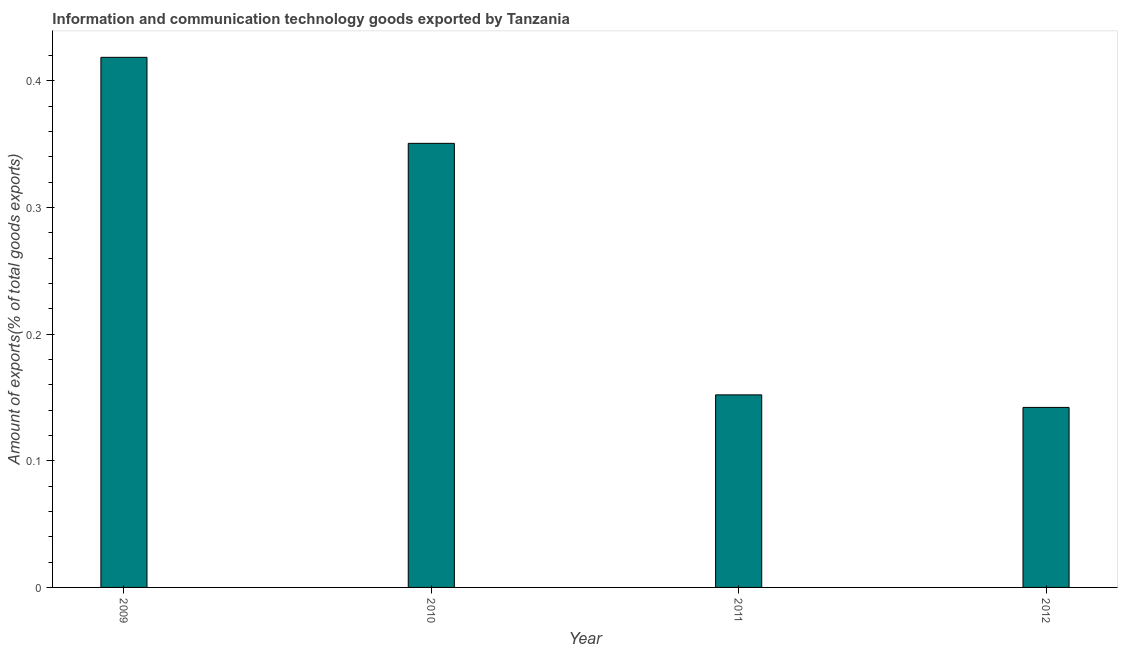Does the graph contain any zero values?
Provide a short and direct response. No. Does the graph contain grids?
Provide a succinct answer. No. What is the title of the graph?
Provide a short and direct response. Information and communication technology goods exported by Tanzania. What is the label or title of the X-axis?
Provide a short and direct response. Year. What is the label or title of the Y-axis?
Ensure brevity in your answer.  Amount of exports(% of total goods exports). What is the amount of ict goods exports in 2011?
Offer a terse response. 0.15. Across all years, what is the maximum amount of ict goods exports?
Offer a terse response. 0.42. Across all years, what is the minimum amount of ict goods exports?
Make the answer very short. 0.14. In which year was the amount of ict goods exports maximum?
Ensure brevity in your answer.  2009. What is the sum of the amount of ict goods exports?
Give a very brief answer. 1.06. What is the difference between the amount of ict goods exports in 2010 and 2011?
Provide a short and direct response. 0.2. What is the average amount of ict goods exports per year?
Ensure brevity in your answer.  0.27. What is the median amount of ict goods exports?
Offer a terse response. 0.25. What is the ratio of the amount of ict goods exports in 2010 to that in 2012?
Your answer should be very brief. 2.47. Is the amount of ict goods exports in 2011 less than that in 2012?
Your answer should be very brief. No. What is the difference between the highest and the second highest amount of ict goods exports?
Your response must be concise. 0.07. What is the difference between the highest and the lowest amount of ict goods exports?
Ensure brevity in your answer.  0.28. What is the difference between two consecutive major ticks on the Y-axis?
Ensure brevity in your answer.  0.1. What is the Amount of exports(% of total goods exports) in 2009?
Provide a succinct answer. 0.42. What is the Amount of exports(% of total goods exports) in 2010?
Offer a terse response. 0.35. What is the Amount of exports(% of total goods exports) of 2011?
Offer a terse response. 0.15. What is the Amount of exports(% of total goods exports) of 2012?
Ensure brevity in your answer.  0.14. What is the difference between the Amount of exports(% of total goods exports) in 2009 and 2010?
Your answer should be compact. 0.07. What is the difference between the Amount of exports(% of total goods exports) in 2009 and 2011?
Provide a succinct answer. 0.27. What is the difference between the Amount of exports(% of total goods exports) in 2009 and 2012?
Offer a very short reply. 0.28. What is the difference between the Amount of exports(% of total goods exports) in 2010 and 2011?
Give a very brief answer. 0.2. What is the difference between the Amount of exports(% of total goods exports) in 2010 and 2012?
Keep it short and to the point. 0.21. What is the difference between the Amount of exports(% of total goods exports) in 2011 and 2012?
Provide a short and direct response. 0.01. What is the ratio of the Amount of exports(% of total goods exports) in 2009 to that in 2010?
Your answer should be very brief. 1.19. What is the ratio of the Amount of exports(% of total goods exports) in 2009 to that in 2011?
Provide a succinct answer. 2.75. What is the ratio of the Amount of exports(% of total goods exports) in 2009 to that in 2012?
Provide a succinct answer. 2.94. What is the ratio of the Amount of exports(% of total goods exports) in 2010 to that in 2011?
Your answer should be compact. 2.31. What is the ratio of the Amount of exports(% of total goods exports) in 2010 to that in 2012?
Your answer should be compact. 2.47. What is the ratio of the Amount of exports(% of total goods exports) in 2011 to that in 2012?
Your response must be concise. 1.07. 